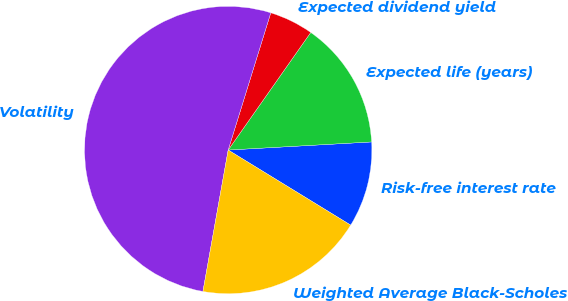Convert chart to OTSL. <chart><loc_0><loc_0><loc_500><loc_500><pie_chart><fcel>Risk-free interest rate<fcel>Expected life (years)<fcel>Expected dividend yield<fcel>Volatility<fcel>Weighted Average Black-Scholes<nl><fcel>9.65%<fcel>14.36%<fcel>4.95%<fcel>51.98%<fcel>19.06%<nl></chart> 